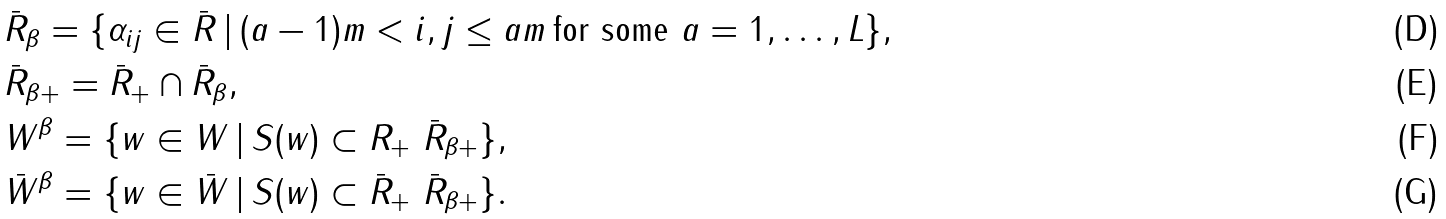<formula> <loc_0><loc_0><loc_500><loc_500>& \bar { R } _ { \beta } = \{ \alpha _ { i j } \in \bar { R } \, | \, ( a - 1 ) m < i , j \leq a m \, \text {for some $a=1,\dots,L$} \} , \\ & \bar { R } _ { \beta + } = \bar { R } _ { + } \cap \bar { R } _ { \beta } , \\ & W ^ { \beta } = \{ w \in W \, | \, S ( w ) \subset R _ { + } \ \bar { R } _ { \beta + } \} , \\ & \bar { W } ^ { \beta } = \{ w \in \bar { W } \, | \, S ( w ) \subset \bar { R } _ { + } \ \bar { R } _ { \beta + } \} .</formula> 